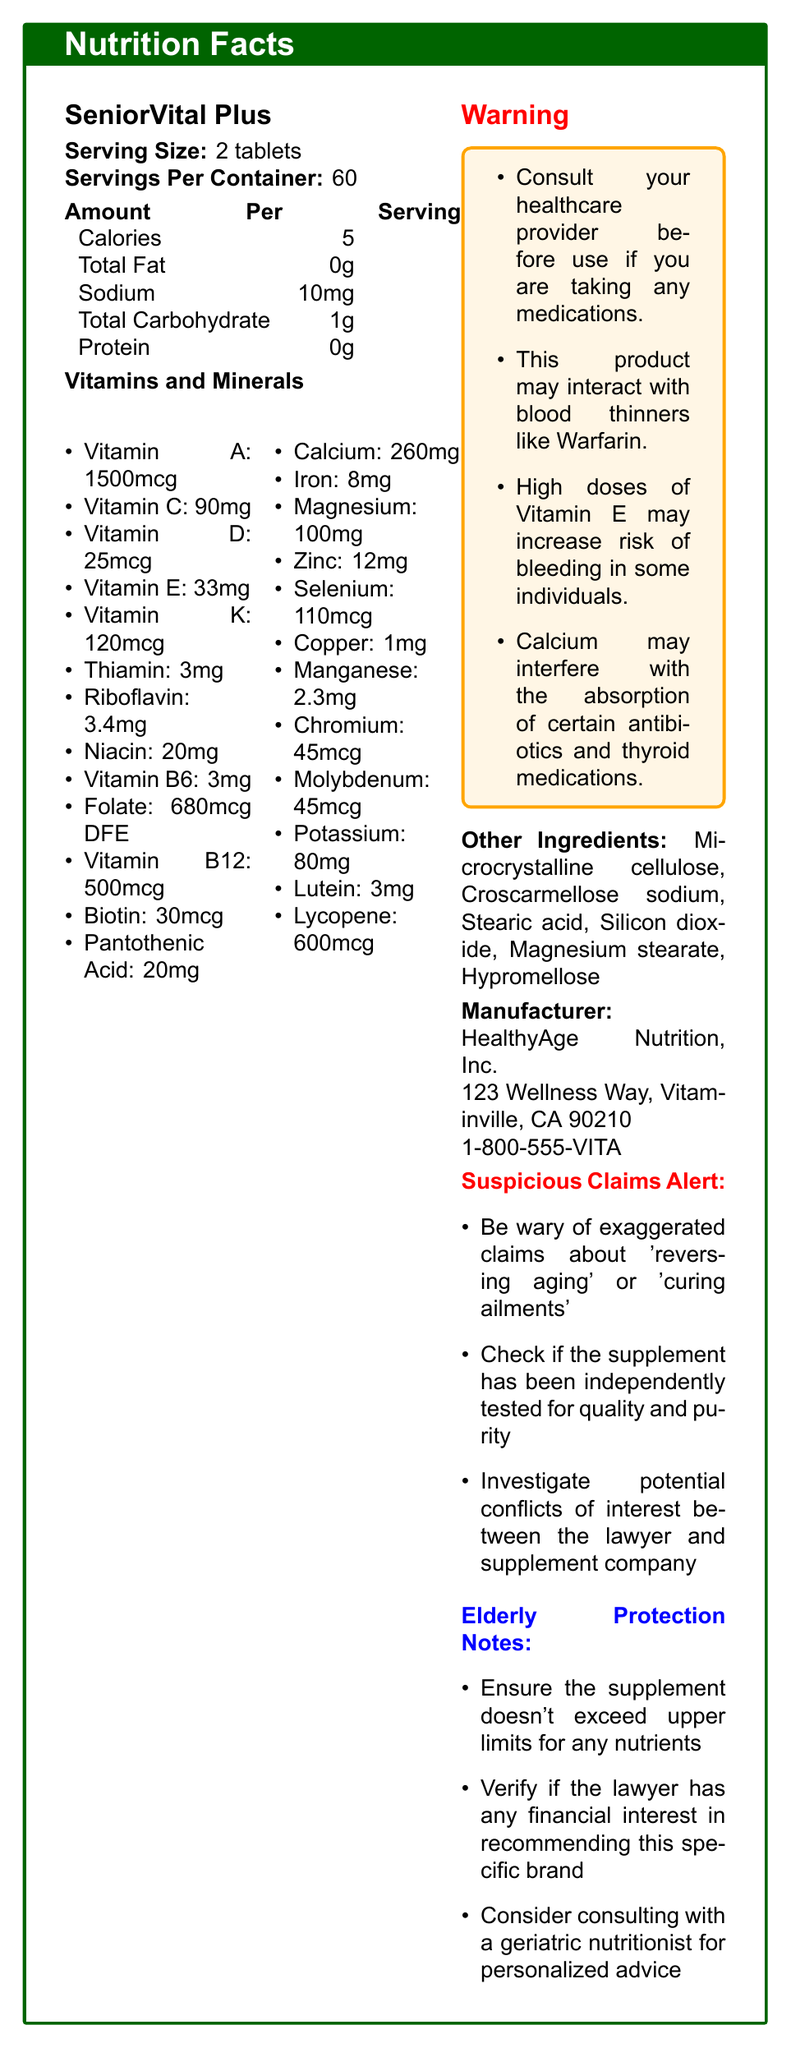what is the serving size of SeniorVital Plus? The serving size is explicitly stated as "Serving Size: 2 tablets".
Answer: 2 tablets how many servings are in one container of SeniorVital Plus? It is directly mentioned as "Servings Per Container: 60".
Answer: 60 servings what is the amount of Vitamin B12 per serving in SeniorVital Plus? The document lists "Vitamin B12: 500mcg" under vitamins and minerals.
Answer: 500mcg Which nutrient has the highest quantity per serving in SeniorVital Plus? Among the listed vitamins and minerals, Vitamin B12 has the highest quantity at 500mcg.
Answer: Vitamin B12 What is one potential interaction warning provided for SeniorVital Plus? The warnings section explicitly states, "This product may interact with blood thinners like Warfarin."
Answer: It may interact with blood thinners like Warfarin. How many calories are in a serving of SeniorVital Plus? The document lists "Calories: 5" under the nutrition facts.
Answer: 5 calories What should you do before using SeniorVital Plus if you are taking other medications? The warning section advises, "Consult your healthcare provider before use if you are taking any medications."
Answer: Consult your healthcare provider Which vitamin in SeniorVital Plus has a quantity of 90mg per serving? The listed quantity for Vitamin C is "Vitamin C: 90mg".
Answer: Vitamin C Which of the following is not listed as an ingredient in SeniorVital Plus? A. Microcrystalline cellulose B. Hypromellose C. Lactose Lactose is not listed in the "Other Ingredients" section, whereas Microcrystalline cellulose and Hypromellose are.
Answer: C. Lactose Which option best describes a suspicious claim alert mentioned in the document? A. Guaranteed cure for all ailments B. Reverse aging process C. Improve general well-being The suspicious claims alert specifically mentions "Be wary of exaggerated claims about 'reversing aging'".
Answer: B. Reverse aging process Does SeniorVital Plus contain any protein? The document explicitly states, "Protein: 0g".
Answer: No Summary: What is the main purpose of the document about SeniorVital Plus? The document lists detailed nutritional facts, potential medication interactions, and other relevant information intended to inform users about the product.
Answer: The document provides nutritional information, warnings, and additional notes about SeniorVital Plus, a senior vitamin supplement. How many mg of calcium are present in one serving of SeniorVital Plus? The document lists "Calcium: 260mg" under vitamins and minerals.
Answer: 260mg What is the address of the manufacturer of SeniorVital Plus? The address is listed under the manufacturer information as "123 Wellness Way, Vitaminville, CA 90210".
Answer: 123 Wellness Way, Vitaminville, CA 90210 Can we ascertain from the document whether the supplement has been independently tested for quality and purity? The suspicious claims alert suggests checking for independent tests, indicating that such information is not provided in the document itself.
Answer: Not enough information Which vitamins in SeniorVital Plus are particularly noted as having interaction warnings? A. Vitamin C and Vitamin D B. Vitamin E and Calcium C. Vitamin A and Biotin The warning section mentions potential interaction risks with "High doses of Vitamin E" and "Calcium".
Answer: B. Vitamin E and Calcium 